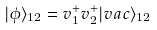Convert formula to latex. <formula><loc_0><loc_0><loc_500><loc_500>| \phi \rangle _ { 1 2 } = v ^ { + } _ { 1 } v ^ { + } _ { 2 } | v a c \rangle _ { 1 2 }</formula> 